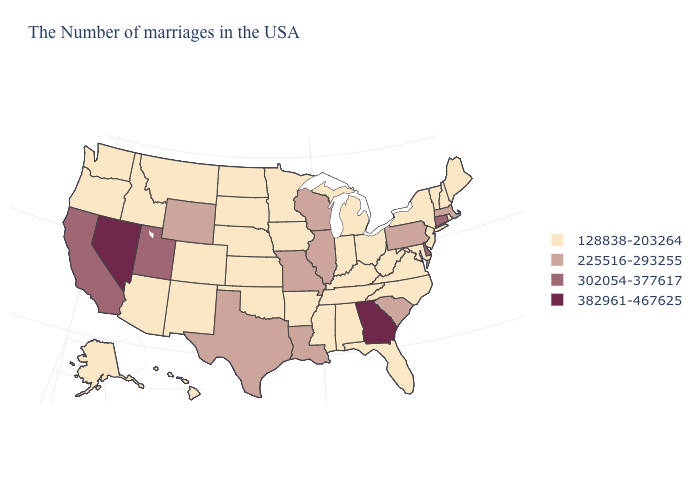Which states have the highest value in the USA?
Concise answer only. Georgia, Nevada. What is the lowest value in the USA?
Short answer required. 128838-203264. What is the value of Vermont?
Short answer required. 128838-203264. Name the states that have a value in the range 302054-377617?
Be succinct. Connecticut, Delaware, Utah, California. Does Georgia have the highest value in the USA?
Be succinct. Yes. What is the value of New Jersey?
Short answer required. 128838-203264. What is the value of Texas?
Be succinct. 225516-293255. Does Nevada have the highest value in the USA?
Short answer required. Yes. What is the value of Texas?
Answer briefly. 225516-293255. Among the states that border Arkansas , does Tennessee have the lowest value?
Be succinct. Yes. Is the legend a continuous bar?
Be succinct. No. Which states have the lowest value in the South?
Be succinct. Maryland, Virginia, North Carolina, West Virginia, Florida, Kentucky, Alabama, Tennessee, Mississippi, Arkansas, Oklahoma. What is the lowest value in the South?
Give a very brief answer. 128838-203264. Is the legend a continuous bar?
Quick response, please. No. 